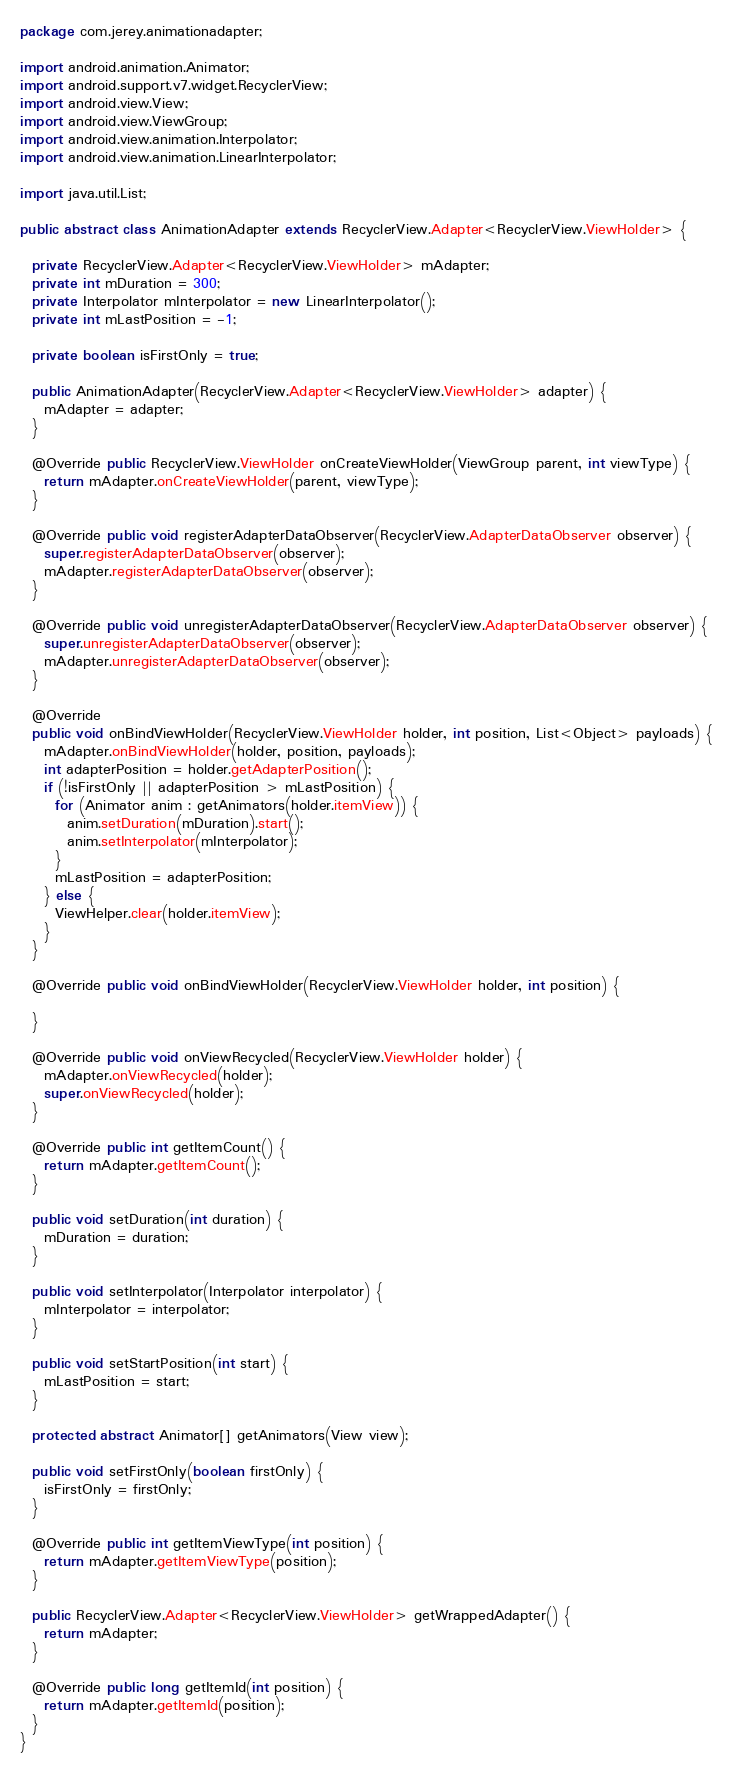Convert code to text. <code><loc_0><loc_0><loc_500><loc_500><_Java_>package com.jerey.animationadapter;

import android.animation.Animator;
import android.support.v7.widget.RecyclerView;
import android.view.View;
import android.view.ViewGroup;
import android.view.animation.Interpolator;
import android.view.animation.LinearInterpolator;

import java.util.List;

public abstract class AnimationAdapter extends RecyclerView.Adapter<RecyclerView.ViewHolder> {

  private RecyclerView.Adapter<RecyclerView.ViewHolder> mAdapter;
  private int mDuration = 300;
  private Interpolator mInterpolator = new LinearInterpolator();
  private int mLastPosition = -1;

  private boolean isFirstOnly = true;

  public AnimationAdapter(RecyclerView.Adapter<RecyclerView.ViewHolder> adapter) {
    mAdapter = adapter;
  }

  @Override public RecyclerView.ViewHolder onCreateViewHolder(ViewGroup parent, int viewType) {
    return mAdapter.onCreateViewHolder(parent, viewType);
  }

  @Override public void registerAdapterDataObserver(RecyclerView.AdapterDataObserver observer) {
    super.registerAdapterDataObserver(observer);
    mAdapter.registerAdapterDataObserver(observer);
  }

  @Override public void unregisterAdapterDataObserver(RecyclerView.AdapterDataObserver observer) {
    super.unregisterAdapterDataObserver(observer);
    mAdapter.unregisterAdapterDataObserver(observer);
  }

  @Override
  public void onBindViewHolder(RecyclerView.ViewHolder holder, int position, List<Object> payloads) {
    mAdapter.onBindViewHolder(holder, position, payloads);
    int adapterPosition = holder.getAdapterPosition();
    if (!isFirstOnly || adapterPosition > mLastPosition) {
      for (Animator anim : getAnimators(holder.itemView)) {
        anim.setDuration(mDuration).start();
        anim.setInterpolator(mInterpolator);
      }
      mLastPosition = adapterPosition;
    } else {
      ViewHelper.clear(holder.itemView);
    }
  }

  @Override public void onBindViewHolder(RecyclerView.ViewHolder holder, int position) {

  }

  @Override public void onViewRecycled(RecyclerView.ViewHolder holder) {
    mAdapter.onViewRecycled(holder);
    super.onViewRecycled(holder);
  }

  @Override public int getItemCount() {
    return mAdapter.getItemCount();
  }

  public void setDuration(int duration) {
    mDuration = duration;
  }

  public void setInterpolator(Interpolator interpolator) {
    mInterpolator = interpolator;
  }

  public void setStartPosition(int start) {
    mLastPosition = start;
  }

  protected abstract Animator[] getAnimators(View view);

  public void setFirstOnly(boolean firstOnly) {
    isFirstOnly = firstOnly;
  }

  @Override public int getItemViewType(int position) {
    return mAdapter.getItemViewType(position);
  }

  public RecyclerView.Adapter<RecyclerView.ViewHolder> getWrappedAdapter() {
    return mAdapter;
  }

  @Override public long getItemId(int position) {
    return mAdapter.getItemId(position);
  }
}
</code> 